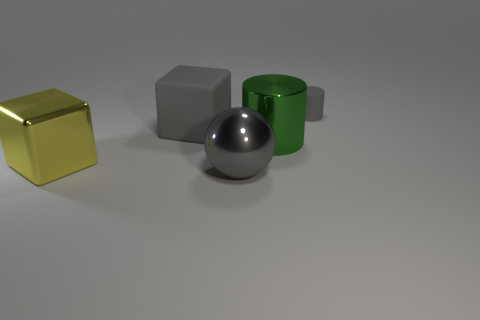Add 3 big metallic balls. How many objects exist? 8 Subtract 0 yellow balls. How many objects are left? 5 Subtract all balls. How many objects are left? 4 Subtract all blue blocks. Subtract all brown cylinders. How many blocks are left? 2 Subtract all green cylinders. How many green balls are left? 0 Subtract all large cyan metallic cylinders. Subtract all tiny gray cylinders. How many objects are left? 4 Add 2 big yellow cubes. How many big yellow cubes are left? 3 Add 1 purple shiny balls. How many purple shiny balls exist? 1 